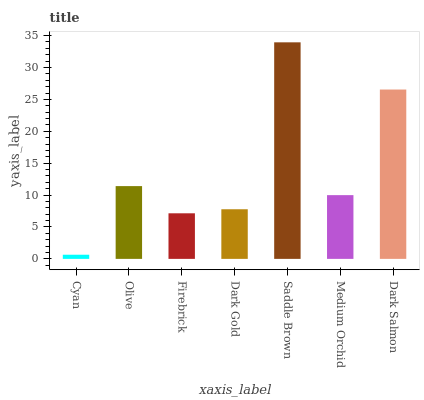Is Olive the minimum?
Answer yes or no. No. Is Olive the maximum?
Answer yes or no. No. Is Olive greater than Cyan?
Answer yes or no. Yes. Is Cyan less than Olive?
Answer yes or no. Yes. Is Cyan greater than Olive?
Answer yes or no. No. Is Olive less than Cyan?
Answer yes or no. No. Is Medium Orchid the high median?
Answer yes or no. Yes. Is Medium Orchid the low median?
Answer yes or no. Yes. Is Saddle Brown the high median?
Answer yes or no. No. Is Saddle Brown the low median?
Answer yes or no. No. 